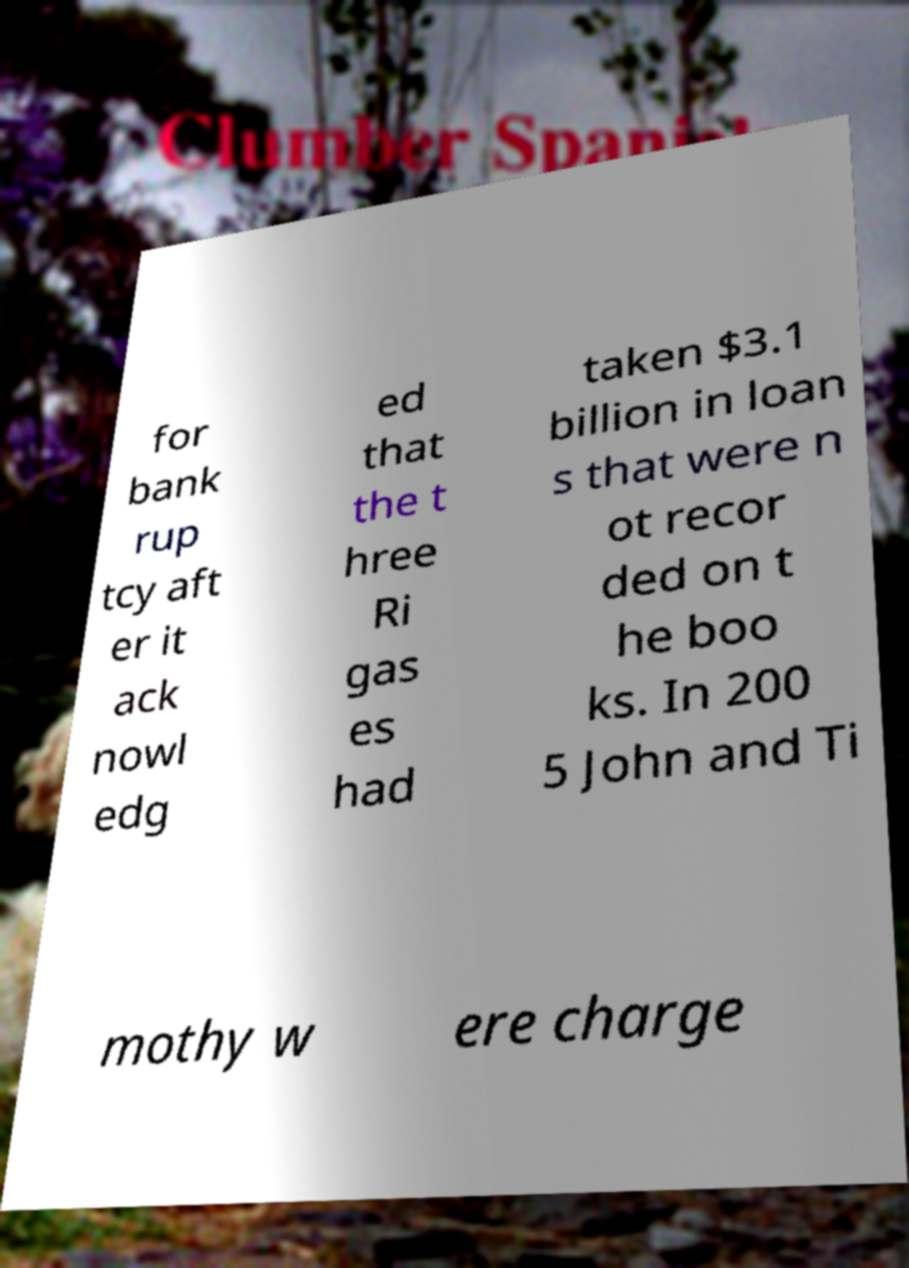Could you extract and type out the text from this image? for bank rup tcy aft er it ack nowl edg ed that the t hree Ri gas es had taken $3.1 billion in loan s that were n ot recor ded on t he boo ks. In 200 5 John and Ti mothy w ere charge 